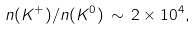<formula> <loc_0><loc_0><loc_500><loc_500>n ( K ^ { + } ) / n ( K ^ { 0 } ) \, \sim \, 2 \times 1 0 ^ { 4 } ,</formula> 